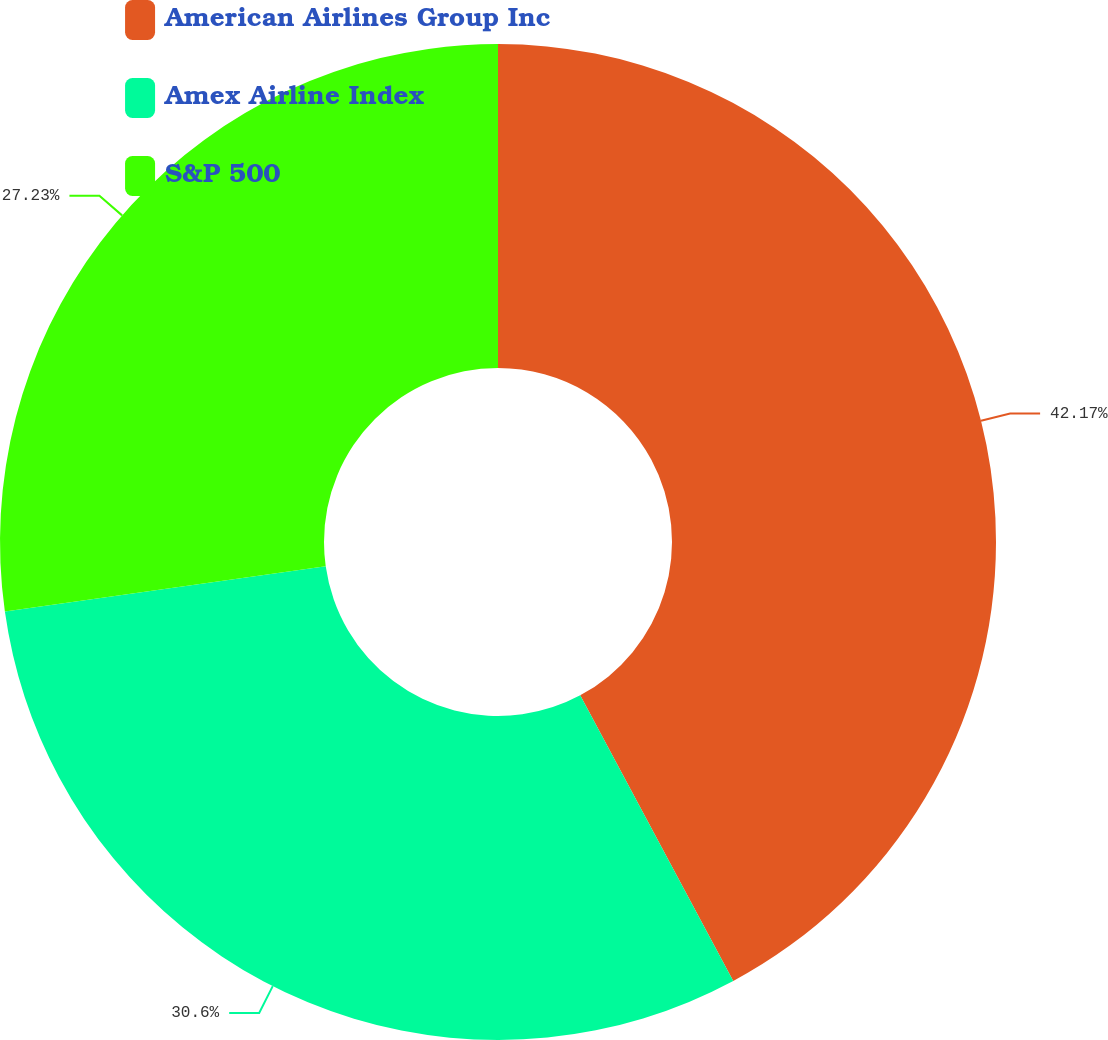Convert chart. <chart><loc_0><loc_0><loc_500><loc_500><pie_chart><fcel>American Airlines Group Inc<fcel>Amex Airline Index<fcel>S&P 500<nl><fcel>42.17%<fcel>30.6%<fcel>27.23%<nl></chart> 